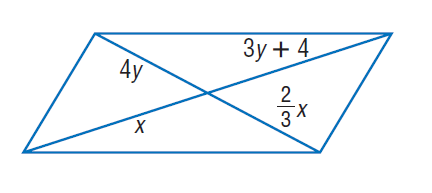Answer the mathemtical geometry problem and directly provide the correct option letter.
Question: Find x and so that the quadrilateral is a parallelogram.
Choices: A: 4 B: 6 C: 8 D: 16 C 